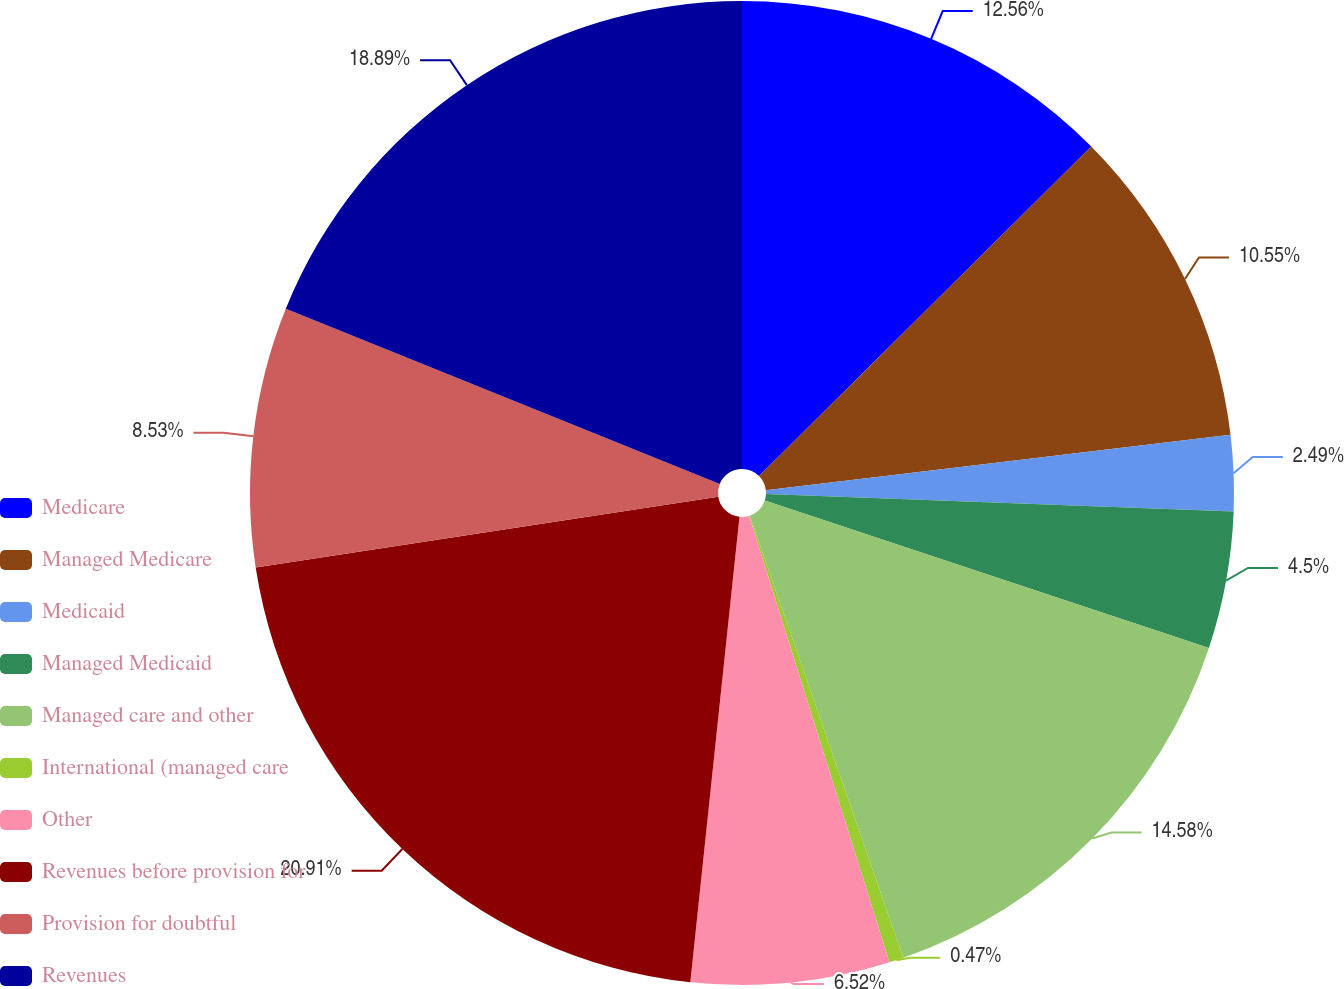<chart> <loc_0><loc_0><loc_500><loc_500><pie_chart><fcel>Medicare<fcel>Managed Medicare<fcel>Medicaid<fcel>Managed Medicaid<fcel>Managed care and other<fcel>International (managed care<fcel>Other<fcel>Revenues before provision for<fcel>Provision for doubtful<fcel>Revenues<nl><fcel>12.56%<fcel>10.55%<fcel>2.49%<fcel>4.5%<fcel>14.58%<fcel>0.47%<fcel>6.52%<fcel>20.9%<fcel>8.53%<fcel>18.89%<nl></chart> 